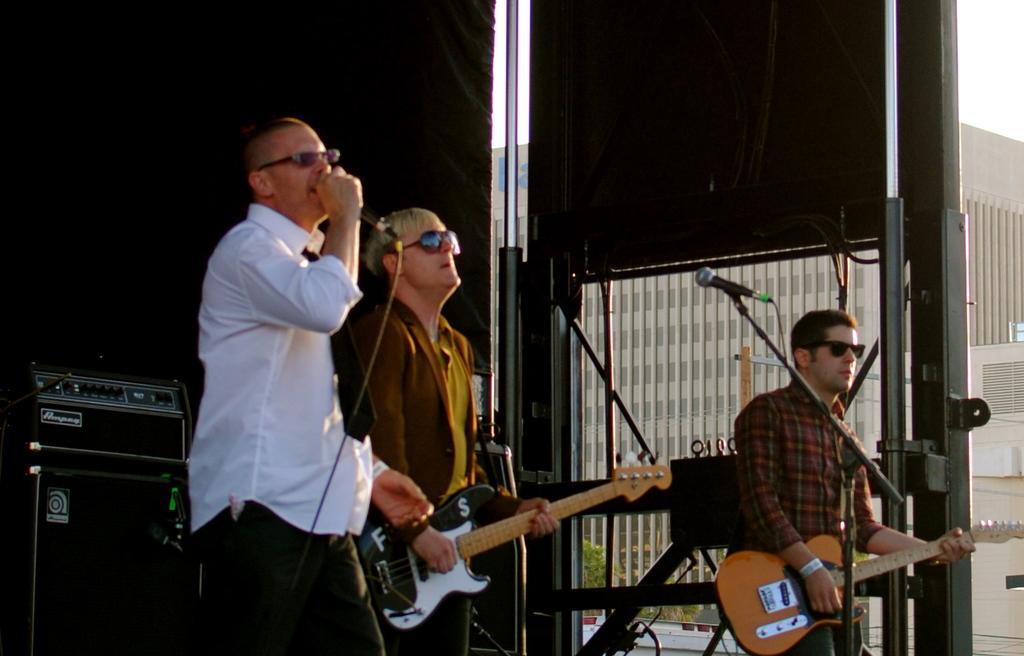Could you give a brief overview of what you see in this image? The picture is clicked in a musical concert where two of the guys are playing guitar and a guy is singing with a mic in front of him. There are also black boxes in background. 